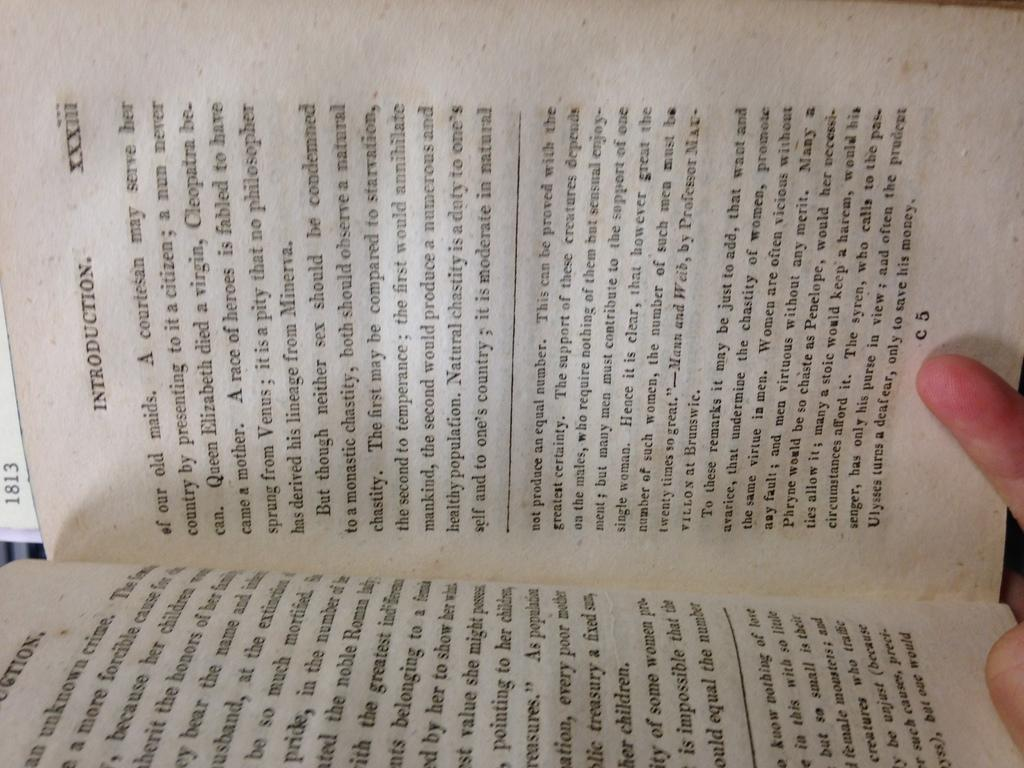<image>
Share a concise interpretation of the image provided. An book that is opened to the introduction section and which is discussing the sexes, chastity, and related topics. 